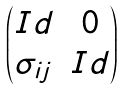<formula> <loc_0><loc_0><loc_500><loc_500>\begin{pmatrix} I d & 0 \\ \sigma _ { i j } & I d \end{pmatrix}</formula> 